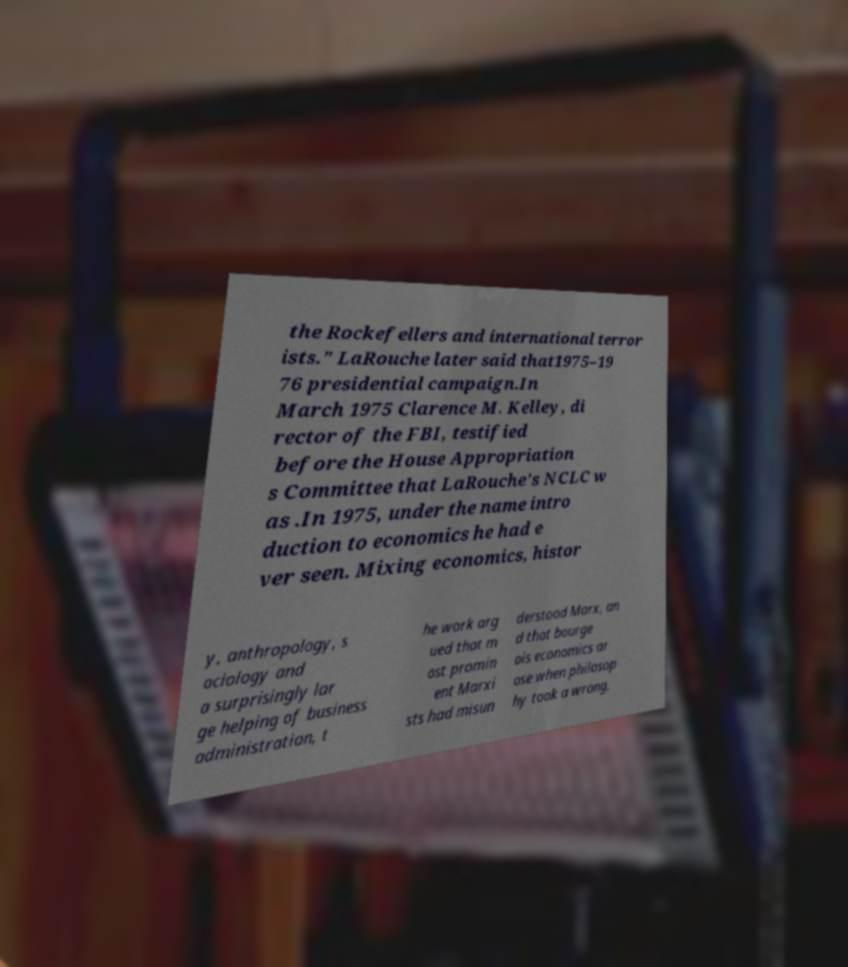Please read and relay the text visible in this image. What does it say? the Rockefellers and international terror ists." LaRouche later said that1975–19 76 presidential campaign.In March 1975 Clarence M. Kelley, di rector of the FBI, testified before the House Appropriation s Committee that LaRouche's NCLC w as .In 1975, under the name intro duction to economics he had e ver seen. Mixing economics, histor y, anthropology, s ociology and a surprisingly lar ge helping of business administration, t he work arg ued that m ost promin ent Marxi sts had misun derstood Marx, an d that bourge ois economics ar ose when philosop hy took a wrong, 